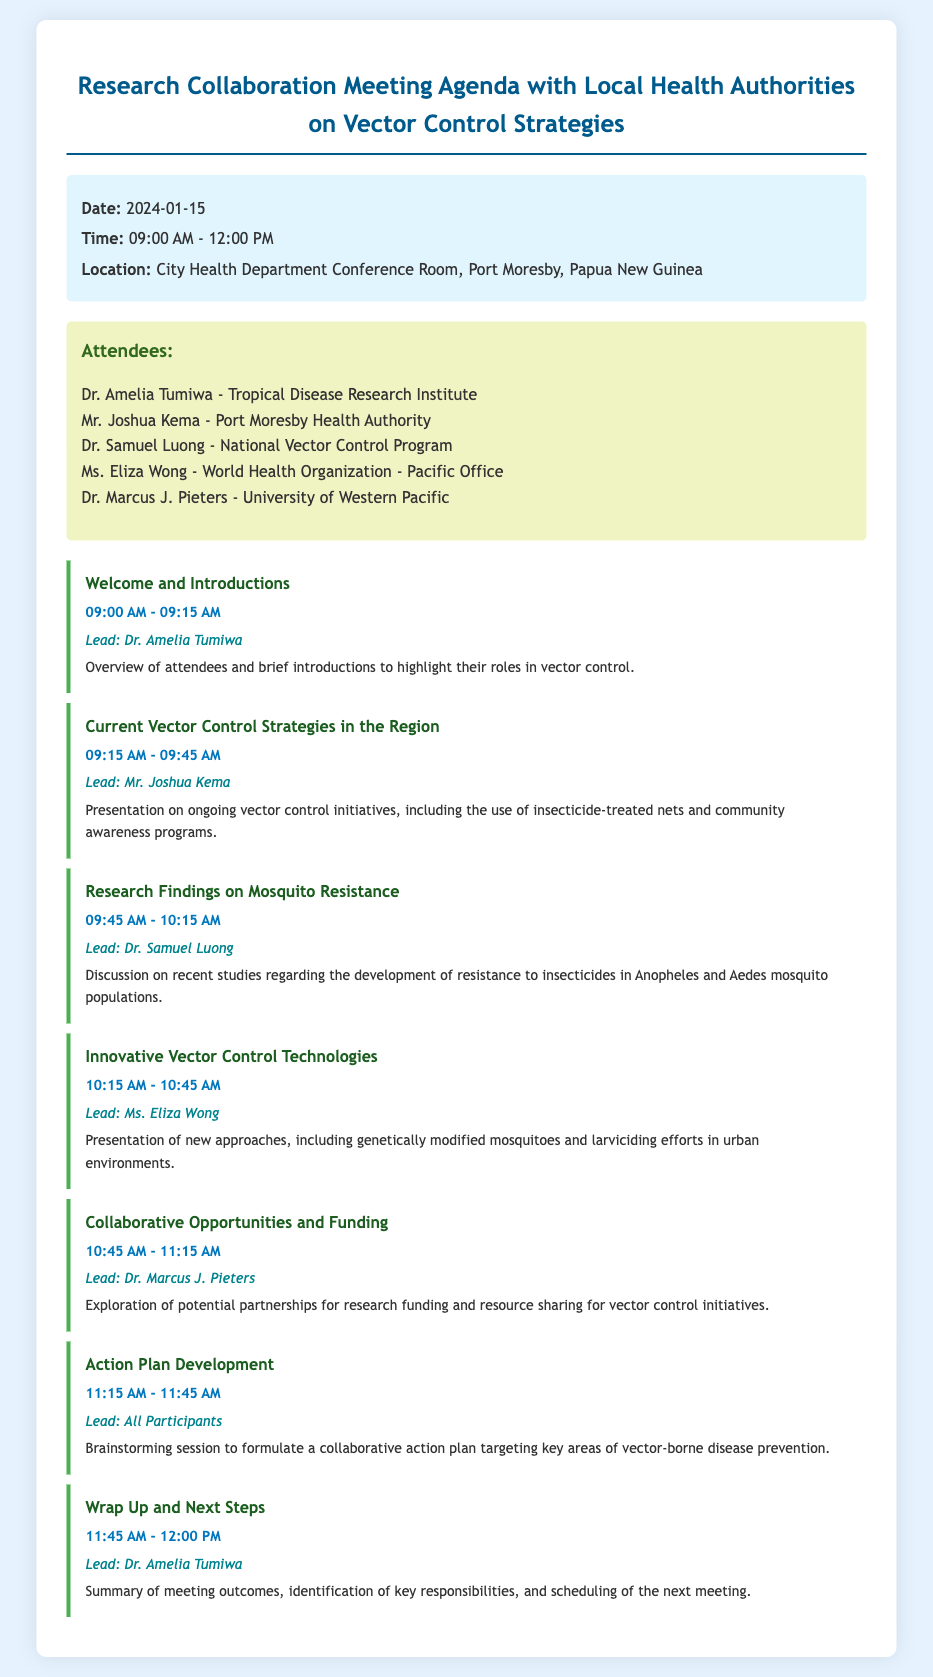What is the date of the meeting? The date of the meeting is specified in the meeting info section of the document.
Answer: 2024-01-15 Who is leading the discussion on innovative vector control technologies? The lead for the innovative vector control technologies agenda item is mentioned in the agenda item details.
Answer: Ms. Eliza Wong What are the start and end times of the meeting? The start and end times are outlined in the meeting info section.
Answer: 09:00 AM - 12:00 PM How long is the presentation on research findings on mosquito resistance? The duration of this agenda item is detailed in the agenda.
Answer: 30 minutes Which organization is Dr. Samuel Luong affiliated with? The attendee list contains the affiliations of each participant, including Dr. Samuel Luong.
Answer: National Vector Control Program What is the focus of the collaborative opportunities and funding agenda item? The agenda item details mention the exploration of partnerships for research funding and resource sharing.
Answer: Partnerships for research funding How many agenda items are listed in the document? The total number of agenda items can be counted from the agenda section.
Answer: 7 What is the location of the meeting? The location is mentioned in the meeting info section of the document.
Answer: City Health Department Conference Room, Port Moresby, Papua New Guinea 